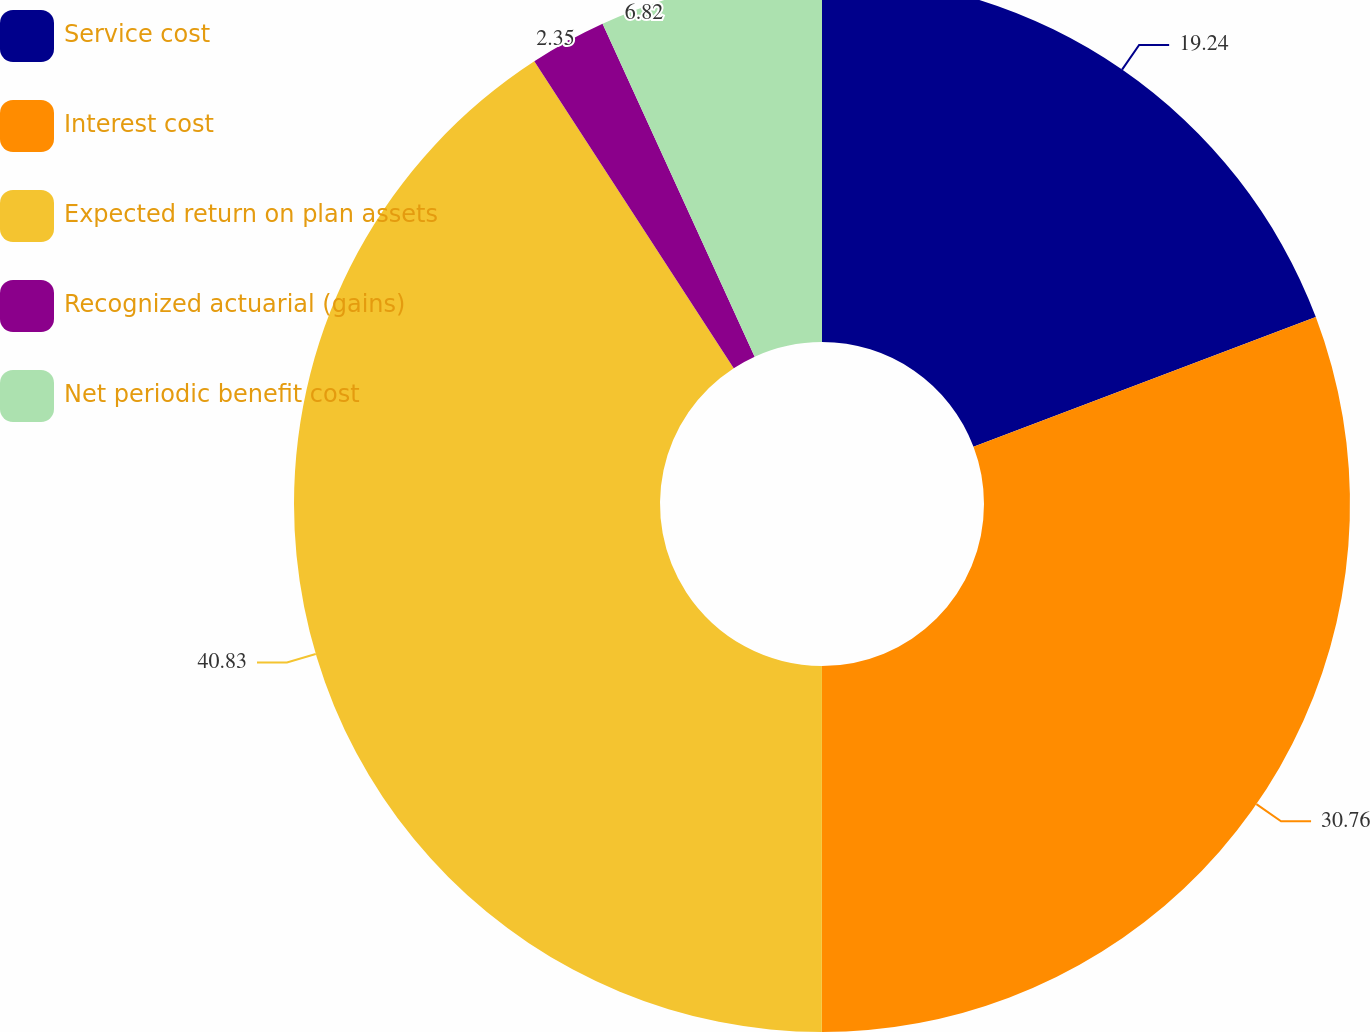Convert chart. <chart><loc_0><loc_0><loc_500><loc_500><pie_chart><fcel>Service cost<fcel>Interest cost<fcel>Expected return on plan assets<fcel>Recognized actuarial (gains)<fcel>Net periodic benefit cost<nl><fcel>19.24%<fcel>30.76%<fcel>40.82%<fcel>2.35%<fcel>6.82%<nl></chart> 